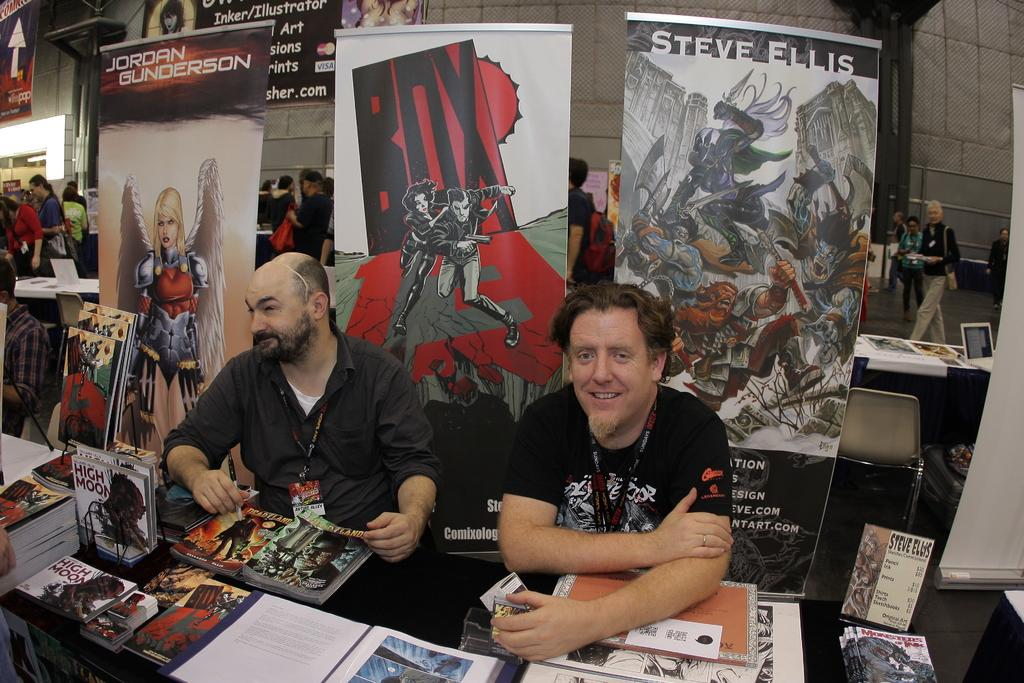<image>
Summarize the visual content of the image. Two guys sitting on a table with images in the background that say BOX or Steve. 